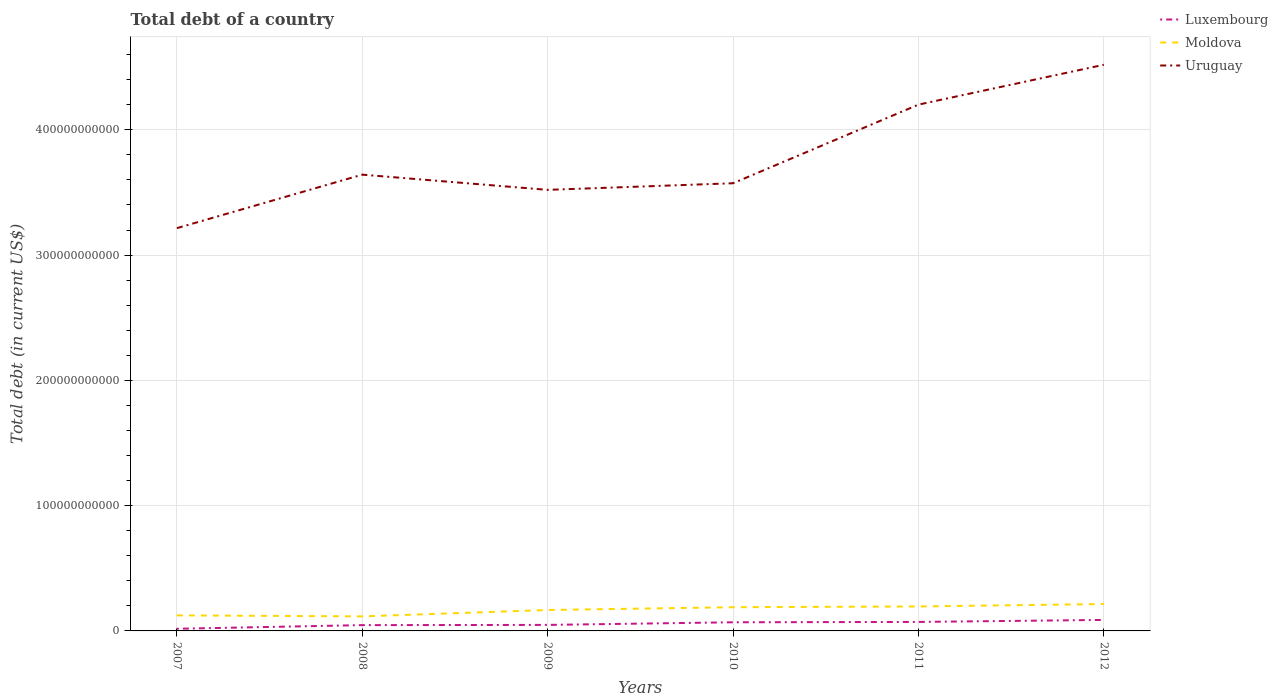How many different coloured lines are there?
Offer a very short reply. 3. Does the line corresponding to Luxembourg intersect with the line corresponding to Moldova?
Make the answer very short. No. Across all years, what is the maximum debt in Luxembourg?
Keep it short and to the point. 1.72e+09. In which year was the debt in Moldova maximum?
Provide a short and direct response. 2008. What is the total debt in Moldova in the graph?
Your response must be concise. 8.12e+08. What is the difference between the highest and the second highest debt in Luxembourg?
Offer a very short reply. 7.06e+09. Is the debt in Moldova strictly greater than the debt in Luxembourg over the years?
Make the answer very short. No. How many lines are there?
Offer a very short reply. 3. How many years are there in the graph?
Provide a short and direct response. 6. What is the difference between two consecutive major ticks on the Y-axis?
Your answer should be very brief. 1.00e+11. Does the graph contain any zero values?
Your answer should be very brief. No. Where does the legend appear in the graph?
Your answer should be very brief. Top right. How are the legend labels stacked?
Your response must be concise. Vertical. What is the title of the graph?
Your answer should be very brief. Total debt of a country. Does "Namibia" appear as one of the legend labels in the graph?
Ensure brevity in your answer.  No. What is the label or title of the Y-axis?
Provide a short and direct response. Total debt (in current US$). What is the Total debt (in current US$) in Luxembourg in 2007?
Make the answer very short. 1.72e+09. What is the Total debt (in current US$) in Moldova in 2007?
Make the answer very short. 1.24e+1. What is the Total debt (in current US$) in Uruguay in 2007?
Offer a very short reply. 3.22e+11. What is the Total debt (in current US$) of Luxembourg in 2008?
Give a very brief answer. 4.63e+09. What is the Total debt (in current US$) of Moldova in 2008?
Provide a short and direct response. 1.16e+1. What is the Total debt (in current US$) in Uruguay in 2008?
Your answer should be very brief. 3.64e+11. What is the Total debt (in current US$) of Luxembourg in 2009?
Provide a succinct answer. 4.80e+09. What is the Total debt (in current US$) in Moldova in 2009?
Keep it short and to the point. 1.67e+1. What is the Total debt (in current US$) of Uruguay in 2009?
Keep it short and to the point. 3.52e+11. What is the Total debt (in current US$) of Luxembourg in 2010?
Make the answer very short. 6.89e+09. What is the Total debt (in current US$) in Moldova in 2010?
Offer a terse response. 1.89e+1. What is the Total debt (in current US$) of Uruguay in 2010?
Offer a terse response. 3.57e+11. What is the Total debt (in current US$) in Luxembourg in 2011?
Ensure brevity in your answer.  7.18e+09. What is the Total debt (in current US$) in Moldova in 2011?
Keep it short and to the point. 1.95e+1. What is the Total debt (in current US$) in Uruguay in 2011?
Your response must be concise. 4.20e+11. What is the Total debt (in current US$) in Luxembourg in 2012?
Your response must be concise. 8.78e+09. What is the Total debt (in current US$) of Moldova in 2012?
Give a very brief answer. 2.15e+1. What is the Total debt (in current US$) of Uruguay in 2012?
Your response must be concise. 4.52e+11. Across all years, what is the maximum Total debt (in current US$) of Luxembourg?
Your answer should be very brief. 8.78e+09. Across all years, what is the maximum Total debt (in current US$) of Moldova?
Make the answer very short. 2.15e+1. Across all years, what is the maximum Total debt (in current US$) in Uruguay?
Your response must be concise. 4.52e+11. Across all years, what is the minimum Total debt (in current US$) of Luxembourg?
Offer a very short reply. 1.72e+09. Across all years, what is the minimum Total debt (in current US$) of Moldova?
Ensure brevity in your answer.  1.16e+1. Across all years, what is the minimum Total debt (in current US$) of Uruguay?
Your response must be concise. 3.22e+11. What is the total Total debt (in current US$) of Luxembourg in the graph?
Make the answer very short. 3.40e+1. What is the total Total debt (in current US$) of Moldova in the graph?
Your answer should be very brief. 1.01e+11. What is the total Total debt (in current US$) of Uruguay in the graph?
Keep it short and to the point. 2.27e+12. What is the difference between the Total debt (in current US$) of Luxembourg in 2007 and that in 2008?
Your answer should be compact. -2.91e+09. What is the difference between the Total debt (in current US$) in Moldova in 2007 and that in 2008?
Your answer should be compact. 8.12e+08. What is the difference between the Total debt (in current US$) in Uruguay in 2007 and that in 2008?
Give a very brief answer. -4.27e+1. What is the difference between the Total debt (in current US$) of Luxembourg in 2007 and that in 2009?
Make the answer very short. -3.08e+09. What is the difference between the Total debt (in current US$) in Moldova in 2007 and that in 2009?
Ensure brevity in your answer.  -4.28e+09. What is the difference between the Total debt (in current US$) of Uruguay in 2007 and that in 2009?
Provide a short and direct response. -3.06e+1. What is the difference between the Total debt (in current US$) in Luxembourg in 2007 and that in 2010?
Your answer should be very brief. -5.17e+09. What is the difference between the Total debt (in current US$) of Moldova in 2007 and that in 2010?
Make the answer very short. -6.51e+09. What is the difference between the Total debt (in current US$) in Uruguay in 2007 and that in 2010?
Your answer should be compact. -3.58e+1. What is the difference between the Total debt (in current US$) of Luxembourg in 2007 and that in 2011?
Give a very brief answer. -5.46e+09. What is the difference between the Total debt (in current US$) in Moldova in 2007 and that in 2011?
Offer a terse response. -7.11e+09. What is the difference between the Total debt (in current US$) of Uruguay in 2007 and that in 2011?
Ensure brevity in your answer.  -9.86e+1. What is the difference between the Total debt (in current US$) in Luxembourg in 2007 and that in 2012?
Keep it short and to the point. -7.06e+09. What is the difference between the Total debt (in current US$) of Moldova in 2007 and that in 2012?
Give a very brief answer. -9.05e+09. What is the difference between the Total debt (in current US$) in Uruguay in 2007 and that in 2012?
Offer a very short reply. -1.30e+11. What is the difference between the Total debt (in current US$) of Luxembourg in 2008 and that in 2009?
Offer a terse response. -1.70e+08. What is the difference between the Total debt (in current US$) of Moldova in 2008 and that in 2009?
Your answer should be very brief. -5.09e+09. What is the difference between the Total debt (in current US$) of Uruguay in 2008 and that in 2009?
Offer a terse response. 1.21e+1. What is the difference between the Total debt (in current US$) of Luxembourg in 2008 and that in 2010?
Make the answer very short. -2.27e+09. What is the difference between the Total debt (in current US$) of Moldova in 2008 and that in 2010?
Your response must be concise. -7.32e+09. What is the difference between the Total debt (in current US$) of Uruguay in 2008 and that in 2010?
Provide a short and direct response. 6.86e+09. What is the difference between the Total debt (in current US$) in Luxembourg in 2008 and that in 2011?
Offer a terse response. -2.55e+09. What is the difference between the Total debt (in current US$) of Moldova in 2008 and that in 2011?
Keep it short and to the point. -7.92e+09. What is the difference between the Total debt (in current US$) of Uruguay in 2008 and that in 2011?
Offer a very short reply. -5.59e+1. What is the difference between the Total debt (in current US$) of Luxembourg in 2008 and that in 2012?
Ensure brevity in your answer.  -4.15e+09. What is the difference between the Total debt (in current US$) of Moldova in 2008 and that in 2012?
Offer a terse response. -9.86e+09. What is the difference between the Total debt (in current US$) of Uruguay in 2008 and that in 2012?
Provide a short and direct response. -8.77e+1. What is the difference between the Total debt (in current US$) in Luxembourg in 2009 and that in 2010?
Your answer should be compact. -2.10e+09. What is the difference between the Total debt (in current US$) in Moldova in 2009 and that in 2010?
Give a very brief answer. -2.22e+09. What is the difference between the Total debt (in current US$) in Uruguay in 2009 and that in 2010?
Your answer should be very brief. -5.28e+09. What is the difference between the Total debt (in current US$) in Luxembourg in 2009 and that in 2011?
Provide a short and direct response. -2.38e+09. What is the difference between the Total debt (in current US$) in Moldova in 2009 and that in 2011?
Your response must be concise. -2.83e+09. What is the difference between the Total debt (in current US$) of Uruguay in 2009 and that in 2011?
Offer a very short reply. -6.80e+1. What is the difference between the Total debt (in current US$) in Luxembourg in 2009 and that in 2012?
Your response must be concise. -3.98e+09. What is the difference between the Total debt (in current US$) of Moldova in 2009 and that in 2012?
Provide a short and direct response. -4.76e+09. What is the difference between the Total debt (in current US$) in Uruguay in 2009 and that in 2012?
Give a very brief answer. -9.99e+1. What is the difference between the Total debt (in current US$) of Luxembourg in 2010 and that in 2011?
Offer a terse response. -2.83e+08. What is the difference between the Total debt (in current US$) of Moldova in 2010 and that in 2011?
Make the answer very short. -6.02e+08. What is the difference between the Total debt (in current US$) of Uruguay in 2010 and that in 2011?
Provide a succinct answer. -6.28e+1. What is the difference between the Total debt (in current US$) in Luxembourg in 2010 and that in 2012?
Ensure brevity in your answer.  -1.88e+09. What is the difference between the Total debt (in current US$) in Moldova in 2010 and that in 2012?
Your response must be concise. -2.54e+09. What is the difference between the Total debt (in current US$) of Uruguay in 2010 and that in 2012?
Your answer should be very brief. -9.46e+1. What is the difference between the Total debt (in current US$) of Luxembourg in 2011 and that in 2012?
Offer a very short reply. -1.60e+09. What is the difference between the Total debt (in current US$) of Moldova in 2011 and that in 2012?
Offer a terse response. -1.94e+09. What is the difference between the Total debt (in current US$) in Uruguay in 2011 and that in 2012?
Keep it short and to the point. -3.18e+1. What is the difference between the Total debt (in current US$) of Luxembourg in 2007 and the Total debt (in current US$) of Moldova in 2008?
Offer a very short reply. -9.88e+09. What is the difference between the Total debt (in current US$) in Luxembourg in 2007 and the Total debt (in current US$) in Uruguay in 2008?
Give a very brief answer. -3.62e+11. What is the difference between the Total debt (in current US$) of Moldova in 2007 and the Total debt (in current US$) of Uruguay in 2008?
Provide a short and direct response. -3.52e+11. What is the difference between the Total debt (in current US$) in Luxembourg in 2007 and the Total debt (in current US$) in Moldova in 2009?
Your response must be concise. -1.50e+1. What is the difference between the Total debt (in current US$) in Luxembourg in 2007 and the Total debt (in current US$) in Uruguay in 2009?
Keep it short and to the point. -3.50e+11. What is the difference between the Total debt (in current US$) in Moldova in 2007 and the Total debt (in current US$) in Uruguay in 2009?
Your answer should be compact. -3.40e+11. What is the difference between the Total debt (in current US$) of Luxembourg in 2007 and the Total debt (in current US$) of Moldova in 2010?
Provide a succinct answer. -1.72e+1. What is the difference between the Total debt (in current US$) of Luxembourg in 2007 and the Total debt (in current US$) of Uruguay in 2010?
Offer a terse response. -3.56e+11. What is the difference between the Total debt (in current US$) of Moldova in 2007 and the Total debt (in current US$) of Uruguay in 2010?
Your answer should be compact. -3.45e+11. What is the difference between the Total debt (in current US$) of Luxembourg in 2007 and the Total debt (in current US$) of Moldova in 2011?
Your response must be concise. -1.78e+1. What is the difference between the Total debt (in current US$) of Luxembourg in 2007 and the Total debt (in current US$) of Uruguay in 2011?
Keep it short and to the point. -4.18e+11. What is the difference between the Total debt (in current US$) in Moldova in 2007 and the Total debt (in current US$) in Uruguay in 2011?
Provide a short and direct response. -4.08e+11. What is the difference between the Total debt (in current US$) of Luxembourg in 2007 and the Total debt (in current US$) of Moldova in 2012?
Give a very brief answer. -1.97e+1. What is the difference between the Total debt (in current US$) of Luxembourg in 2007 and the Total debt (in current US$) of Uruguay in 2012?
Your answer should be very brief. -4.50e+11. What is the difference between the Total debt (in current US$) in Moldova in 2007 and the Total debt (in current US$) in Uruguay in 2012?
Your answer should be compact. -4.40e+11. What is the difference between the Total debt (in current US$) of Luxembourg in 2008 and the Total debt (in current US$) of Moldova in 2009?
Ensure brevity in your answer.  -1.21e+1. What is the difference between the Total debt (in current US$) in Luxembourg in 2008 and the Total debt (in current US$) in Uruguay in 2009?
Your answer should be very brief. -3.47e+11. What is the difference between the Total debt (in current US$) in Moldova in 2008 and the Total debt (in current US$) in Uruguay in 2009?
Provide a short and direct response. -3.40e+11. What is the difference between the Total debt (in current US$) in Luxembourg in 2008 and the Total debt (in current US$) in Moldova in 2010?
Your answer should be compact. -1.43e+1. What is the difference between the Total debt (in current US$) in Luxembourg in 2008 and the Total debt (in current US$) in Uruguay in 2010?
Ensure brevity in your answer.  -3.53e+11. What is the difference between the Total debt (in current US$) in Moldova in 2008 and the Total debt (in current US$) in Uruguay in 2010?
Keep it short and to the point. -3.46e+11. What is the difference between the Total debt (in current US$) of Luxembourg in 2008 and the Total debt (in current US$) of Moldova in 2011?
Your answer should be compact. -1.49e+1. What is the difference between the Total debt (in current US$) of Luxembourg in 2008 and the Total debt (in current US$) of Uruguay in 2011?
Ensure brevity in your answer.  -4.15e+11. What is the difference between the Total debt (in current US$) of Moldova in 2008 and the Total debt (in current US$) of Uruguay in 2011?
Offer a very short reply. -4.09e+11. What is the difference between the Total debt (in current US$) of Luxembourg in 2008 and the Total debt (in current US$) of Moldova in 2012?
Your answer should be compact. -1.68e+1. What is the difference between the Total debt (in current US$) of Luxembourg in 2008 and the Total debt (in current US$) of Uruguay in 2012?
Give a very brief answer. -4.47e+11. What is the difference between the Total debt (in current US$) in Moldova in 2008 and the Total debt (in current US$) in Uruguay in 2012?
Your answer should be compact. -4.40e+11. What is the difference between the Total debt (in current US$) of Luxembourg in 2009 and the Total debt (in current US$) of Moldova in 2010?
Your answer should be compact. -1.41e+1. What is the difference between the Total debt (in current US$) in Luxembourg in 2009 and the Total debt (in current US$) in Uruguay in 2010?
Your answer should be compact. -3.53e+11. What is the difference between the Total debt (in current US$) of Moldova in 2009 and the Total debt (in current US$) of Uruguay in 2010?
Give a very brief answer. -3.41e+11. What is the difference between the Total debt (in current US$) of Luxembourg in 2009 and the Total debt (in current US$) of Moldova in 2011?
Your response must be concise. -1.47e+1. What is the difference between the Total debt (in current US$) of Luxembourg in 2009 and the Total debt (in current US$) of Uruguay in 2011?
Keep it short and to the point. -4.15e+11. What is the difference between the Total debt (in current US$) in Moldova in 2009 and the Total debt (in current US$) in Uruguay in 2011?
Make the answer very short. -4.03e+11. What is the difference between the Total debt (in current US$) of Luxembourg in 2009 and the Total debt (in current US$) of Moldova in 2012?
Keep it short and to the point. -1.67e+1. What is the difference between the Total debt (in current US$) of Luxembourg in 2009 and the Total debt (in current US$) of Uruguay in 2012?
Ensure brevity in your answer.  -4.47e+11. What is the difference between the Total debt (in current US$) in Moldova in 2009 and the Total debt (in current US$) in Uruguay in 2012?
Provide a short and direct response. -4.35e+11. What is the difference between the Total debt (in current US$) in Luxembourg in 2010 and the Total debt (in current US$) in Moldova in 2011?
Your answer should be compact. -1.26e+1. What is the difference between the Total debt (in current US$) in Luxembourg in 2010 and the Total debt (in current US$) in Uruguay in 2011?
Offer a terse response. -4.13e+11. What is the difference between the Total debt (in current US$) in Moldova in 2010 and the Total debt (in current US$) in Uruguay in 2011?
Keep it short and to the point. -4.01e+11. What is the difference between the Total debt (in current US$) of Luxembourg in 2010 and the Total debt (in current US$) of Moldova in 2012?
Make the answer very short. -1.46e+1. What is the difference between the Total debt (in current US$) of Luxembourg in 2010 and the Total debt (in current US$) of Uruguay in 2012?
Offer a terse response. -4.45e+11. What is the difference between the Total debt (in current US$) in Moldova in 2010 and the Total debt (in current US$) in Uruguay in 2012?
Give a very brief answer. -4.33e+11. What is the difference between the Total debt (in current US$) in Luxembourg in 2011 and the Total debt (in current US$) in Moldova in 2012?
Offer a terse response. -1.43e+1. What is the difference between the Total debt (in current US$) of Luxembourg in 2011 and the Total debt (in current US$) of Uruguay in 2012?
Provide a succinct answer. -4.45e+11. What is the difference between the Total debt (in current US$) in Moldova in 2011 and the Total debt (in current US$) in Uruguay in 2012?
Provide a short and direct response. -4.32e+11. What is the average Total debt (in current US$) in Luxembourg per year?
Offer a terse response. 5.67e+09. What is the average Total debt (in current US$) in Moldova per year?
Offer a very short reply. 1.68e+1. What is the average Total debt (in current US$) of Uruguay per year?
Your response must be concise. 3.78e+11. In the year 2007, what is the difference between the Total debt (in current US$) in Luxembourg and Total debt (in current US$) in Moldova?
Offer a very short reply. -1.07e+1. In the year 2007, what is the difference between the Total debt (in current US$) of Luxembourg and Total debt (in current US$) of Uruguay?
Keep it short and to the point. -3.20e+11. In the year 2007, what is the difference between the Total debt (in current US$) in Moldova and Total debt (in current US$) in Uruguay?
Your answer should be very brief. -3.09e+11. In the year 2008, what is the difference between the Total debt (in current US$) in Luxembourg and Total debt (in current US$) in Moldova?
Provide a succinct answer. -6.98e+09. In the year 2008, what is the difference between the Total debt (in current US$) in Luxembourg and Total debt (in current US$) in Uruguay?
Provide a succinct answer. -3.60e+11. In the year 2008, what is the difference between the Total debt (in current US$) in Moldova and Total debt (in current US$) in Uruguay?
Give a very brief answer. -3.53e+11. In the year 2009, what is the difference between the Total debt (in current US$) in Luxembourg and Total debt (in current US$) in Moldova?
Make the answer very short. -1.19e+1. In the year 2009, what is the difference between the Total debt (in current US$) of Luxembourg and Total debt (in current US$) of Uruguay?
Make the answer very short. -3.47e+11. In the year 2009, what is the difference between the Total debt (in current US$) of Moldova and Total debt (in current US$) of Uruguay?
Ensure brevity in your answer.  -3.35e+11. In the year 2010, what is the difference between the Total debt (in current US$) in Luxembourg and Total debt (in current US$) in Moldova?
Provide a succinct answer. -1.20e+1. In the year 2010, what is the difference between the Total debt (in current US$) of Luxembourg and Total debt (in current US$) of Uruguay?
Keep it short and to the point. -3.50e+11. In the year 2010, what is the difference between the Total debt (in current US$) of Moldova and Total debt (in current US$) of Uruguay?
Your response must be concise. -3.38e+11. In the year 2011, what is the difference between the Total debt (in current US$) of Luxembourg and Total debt (in current US$) of Moldova?
Your response must be concise. -1.23e+1. In the year 2011, what is the difference between the Total debt (in current US$) in Luxembourg and Total debt (in current US$) in Uruguay?
Provide a succinct answer. -4.13e+11. In the year 2011, what is the difference between the Total debt (in current US$) in Moldova and Total debt (in current US$) in Uruguay?
Provide a succinct answer. -4.01e+11. In the year 2012, what is the difference between the Total debt (in current US$) in Luxembourg and Total debt (in current US$) in Moldova?
Your answer should be compact. -1.27e+1. In the year 2012, what is the difference between the Total debt (in current US$) of Luxembourg and Total debt (in current US$) of Uruguay?
Your response must be concise. -4.43e+11. In the year 2012, what is the difference between the Total debt (in current US$) in Moldova and Total debt (in current US$) in Uruguay?
Provide a succinct answer. -4.30e+11. What is the ratio of the Total debt (in current US$) in Luxembourg in 2007 to that in 2008?
Your answer should be compact. 0.37. What is the ratio of the Total debt (in current US$) in Moldova in 2007 to that in 2008?
Ensure brevity in your answer.  1.07. What is the ratio of the Total debt (in current US$) in Uruguay in 2007 to that in 2008?
Provide a succinct answer. 0.88. What is the ratio of the Total debt (in current US$) in Luxembourg in 2007 to that in 2009?
Give a very brief answer. 0.36. What is the ratio of the Total debt (in current US$) in Moldova in 2007 to that in 2009?
Offer a very short reply. 0.74. What is the ratio of the Total debt (in current US$) of Uruguay in 2007 to that in 2009?
Offer a terse response. 0.91. What is the ratio of the Total debt (in current US$) in Luxembourg in 2007 to that in 2010?
Offer a terse response. 0.25. What is the ratio of the Total debt (in current US$) of Moldova in 2007 to that in 2010?
Keep it short and to the point. 0.66. What is the ratio of the Total debt (in current US$) in Uruguay in 2007 to that in 2010?
Offer a very short reply. 0.9. What is the ratio of the Total debt (in current US$) in Luxembourg in 2007 to that in 2011?
Offer a very short reply. 0.24. What is the ratio of the Total debt (in current US$) in Moldova in 2007 to that in 2011?
Give a very brief answer. 0.64. What is the ratio of the Total debt (in current US$) of Uruguay in 2007 to that in 2011?
Ensure brevity in your answer.  0.77. What is the ratio of the Total debt (in current US$) of Luxembourg in 2007 to that in 2012?
Provide a short and direct response. 0.2. What is the ratio of the Total debt (in current US$) of Moldova in 2007 to that in 2012?
Provide a succinct answer. 0.58. What is the ratio of the Total debt (in current US$) of Uruguay in 2007 to that in 2012?
Provide a succinct answer. 0.71. What is the ratio of the Total debt (in current US$) of Luxembourg in 2008 to that in 2009?
Give a very brief answer. 0.96. What is the ratio of the Total debt (in current US$) in Moldova in 2008 to that in 2009?
Keep it short and to the point. 0.69. What is the ratio of the Total debt (in current US$) in Uruguay in 2008 to that in 2009?
Make the answer very short. 1.03. What is the ratio of the Total debt (in current US$) in Luxembourg in 2008 to that in 2010?
Keep it short and to the point. 0.67. What is the ratio of the Total debt (in current US$) in Moldova in 2008 to that in 2010?
Offer a terse response. 0.61. What is the ratio of the Total debt (in current US$) of Uruguay in 2008 to that in 2010?
Give a very brief answer. 1.02. What is the ratio of the Total debt (in current US$) of Luxembourg in 2008 to that in 2011?
Ensure brevity in your answer.  0.64. What is the ratio of the Total debt (in current US$) in Moldova in 2008 to that in 2011?
Provide a short and direct response. 0.59. What is the ratio of the Total debt (in current US$) of Uruguay in 2008 to that in 2011?
Provide a short and direct response. 0.87. What is the ratio of the Total debt (in current US$) of Luxembourg in 2008 to that in 2012?
Your response must be concise. 0.53. What is the ratio of the Total debt (in current US$) in Moldova in 2008 to that in 2012?
Give a very brief answer. 0.54. What is the ratio of the Total debt (in current US$) in Uruguay in 2008 to that in 2012?
Your answer should be compact. 0.81. What is the ratio of the Total debt (in current US$) in Luxembourg in 2009 to that in 2010?
Ensure brevity in your answer.  0.7. What is the ratio of the Total debt (in current US$) in Moldova in 2009 to that in 2010?
Your answer should be compact. 0.88. What is the ratio of the Total debt (in current US$) in Uruguay in 2009 to that in 2010?
Ensure brevity in your answer.  0.99. What is the ratio of the Total debt (in current US$) in Luxembourg in 2009 to that in 2011?
Give a very brief answer. 0.67. What is the ratio of the Total debt (in current US$) in Moldova in 2009 to that in 2011?
Your answer should be compact. 0.86. What is the ratio of the Total debt (in current US$) in Uruguay in 2009 to that in 2011?
Make the answer very short. 0.84. What is the ratio of the Total debt (in current US$) in Luxembourg in 2009 to that in 2012?
Provide a succinct answer. 0.55. What is the ratio of the Total debt (in current US$) in Moldova in 2009 to that in 2012?
Your response must be concise. 0.78. What is the ratio of the Total debt (in current US$) in Uruguay in 2009 to that in 2012?
Keep it short and to the point. 0.78. What is the ratio of the Total debt (in current US$) of Luxembourg in 2010 to that in 2011?
Provide a short and direct response. 0.96. What is the ratio of the Total debt (in current US$) in Moldova in 2010 to that in 2011?
Ensure brevity in your answer.  0.97. What is the ratio of the Total debt (in current US$) of Uruguay in 2010 to that in 2011?
Ensure brevity in your answer.  0.85. What is the ratio of the Total debt (in current US$) in Luxembourg in 2010 to that in 2012?
Provide a succinct answer. 0.79. What is the ratio of the Total debt (in current US$) in Moldova in 2010 to that in 2012?
Your answer should be very brief. 0.88. What is the ratio of the Total debt (in current US$) in Uruguay in 2010 to that in 2012?
Give a very brief answer. 0.79. What is the ratio of the Total debt (in current US$) of Luxembourg in 2011 to that in 2012?
Your answer should be very brief. 0.82. What is the ratio of the Total debt (in current US$) in Moldova in 2011 to that in 2012?
Your response must be concise. 0.91. What is the ratio of the Total debt (in current US$) in Uruguay in 2011 to that in 2012?
Provide a short and direct response. 0.93. What is the difference between the highest and the second highest Total debt (in current US$) of Luxembourg?
Give a very brief answer. 1.60e+09. What is the difference between the highest and the second highest Total debt (in current US$) of Moldova?
Provide a succinct answer. 1.94e+09. What is the difference between the highest and the second highest Total debt (in current US$) of Uruguay?
Your response must be concise. 3.18e+1. What is the difference between the highest and the lowest Total debt (in current US$) of Luxembourg?
Provide a short and direct response. 7.06e+09. What is the difference between the highest and the lowest Total debt (in current US$) in Moldova?
Give a very brief answer. 9.86e+09. What is the difference between the highest and the lowest Total debt (in current US$) in Uruguay?
Make the answer very short. 1.30e+11. 